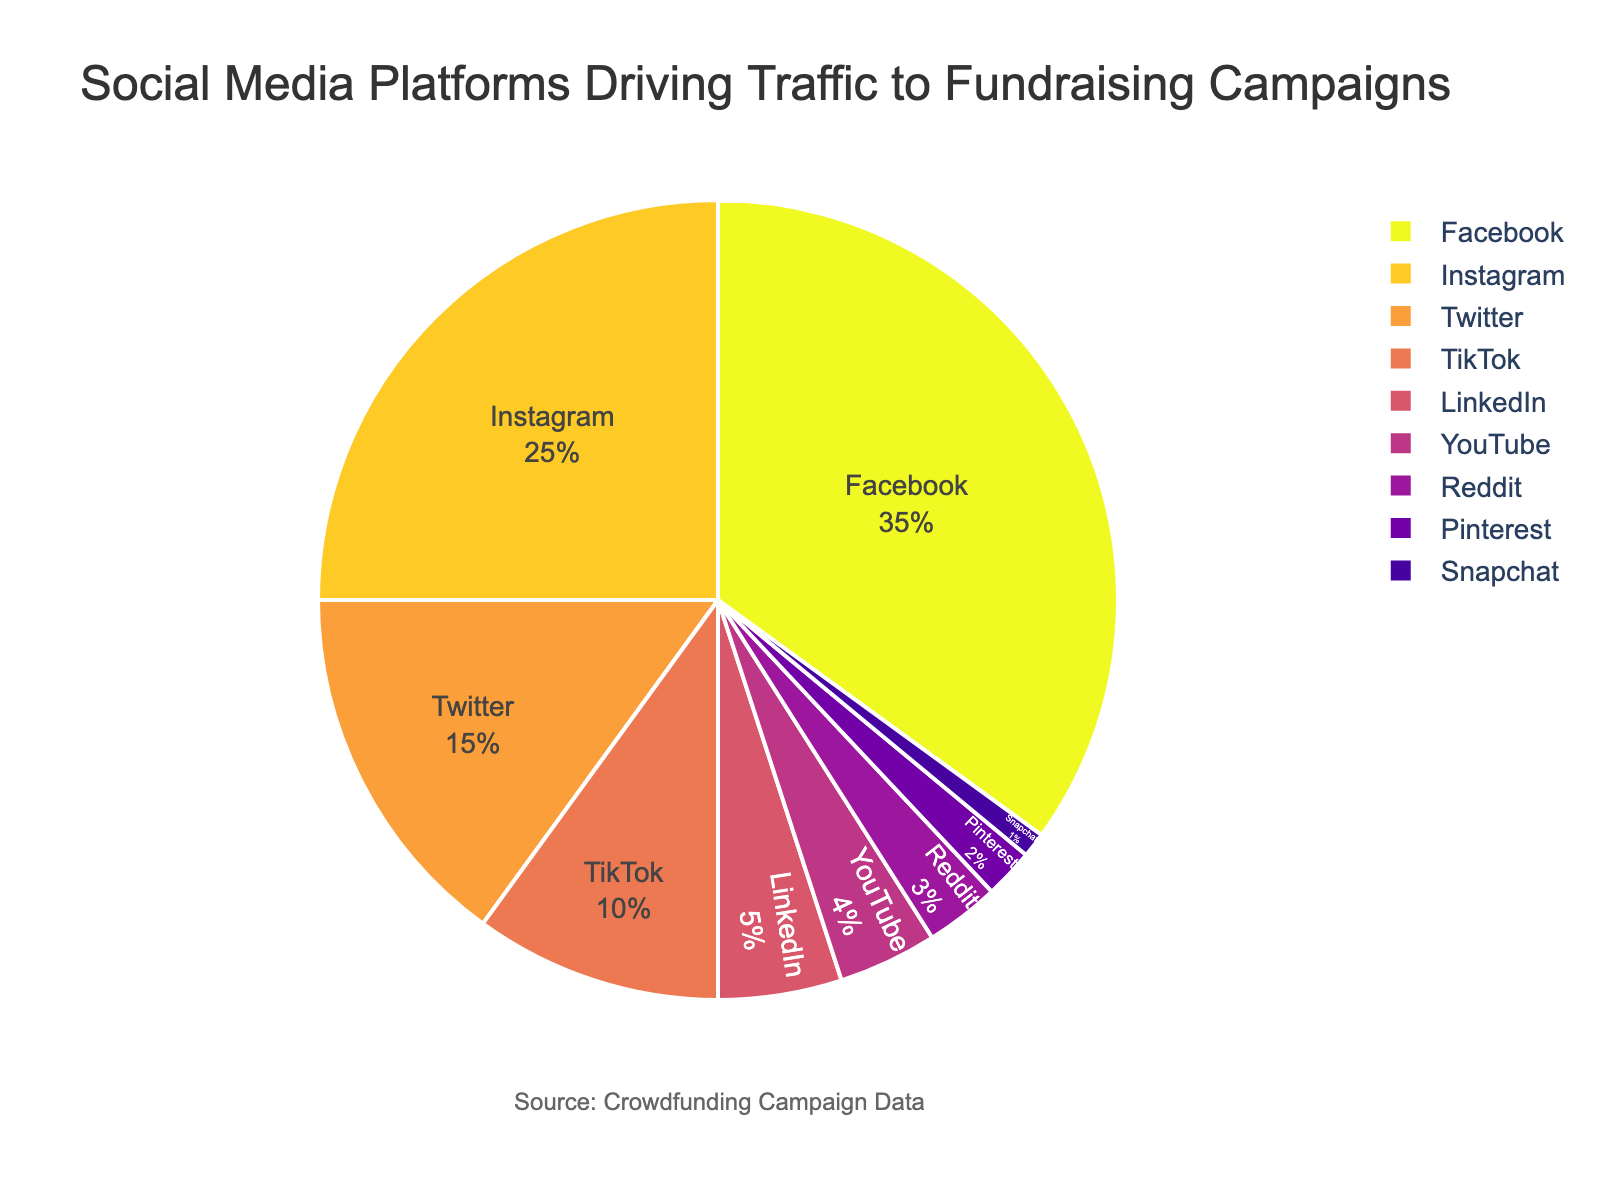Which social media platform drives the most traffic to fundraising campaigns? The pie chart shows the percentages of traffic driven by each social media platform. The platform with the largest segment is Facebook.
Answer: Facebook Which two platforms combined drive 40% of the traffic? Looking at the pie chart, Facebook drives 35% and LinkedIn drives 5%. Adding these two percentages gives us 40%.
Answer: Facebook and LinkedIn How does the traffic driven by Instagram compare to that driven by TikTok? The pie chart shows that Instagram drives 25% of the traffic, while TikTok drives 10%. 25% is greater than 10% by 15 percentage points.
Answer: Instagram drives more traffic by 15 percentage points Which platform drives the least amount of traffic, and what's its percentage? The smallest segment in the pie chart is Snapchat, which drives 1% of the traffic.
Answer: Snapchat, 1% How much more traffic does Facebook drive compared to Twitter? Inspecting the pie chart, Facebook drives 35% of the traffic, and Twitter drives 15%. The difference between these two percentages is 35% - 15% = 20%.
Answer: 20% What percent of the traffic is driven by platforms other than Facebook and Instagram? Summing the percentages of all platforms except Facebook and Instagram: 15% (Twitter) + 10% (TikTok) + 5% (LinkedIn) + 4% (YouTube) + 3% (Reddit) + 2% (Pinterest) + 1% (Snapchat) = 40%.
Answer: 40% How do the combined contributions of YouTube and Reddit compare to TikTok's contribution? YouTube drives 4% and Reddit drives 3%. Their combined contribution is 4% + 3% = 7%. TikTok drives 10%, which is 3 percentage points higher than the combined contributions of YouTube and Reddit.
Answer: TikTok drives more by 3 percentage points Which two platforms have a combined contribution of 3%? The pie chart shows that Reddit contributes 3%. No other combination of platforms adds up to exactly 3%.
Answer: Reddit What percentage of traffic do the top three platforms drive? The top three platforms are Facebook (35%), Instagram (25%), and Twitter (15%). Adding these percentages gives 35% + 25% + 15% = 75%.
Answer: 75% How does LinkedIn's contribution compare to YouTube's? LinkedIn drives 5% of the traffic and YouTube drives 4%. LinkedIn's contribution is 1 percentage point higher than YouTube's.
Answer: 1 percentage point higher 